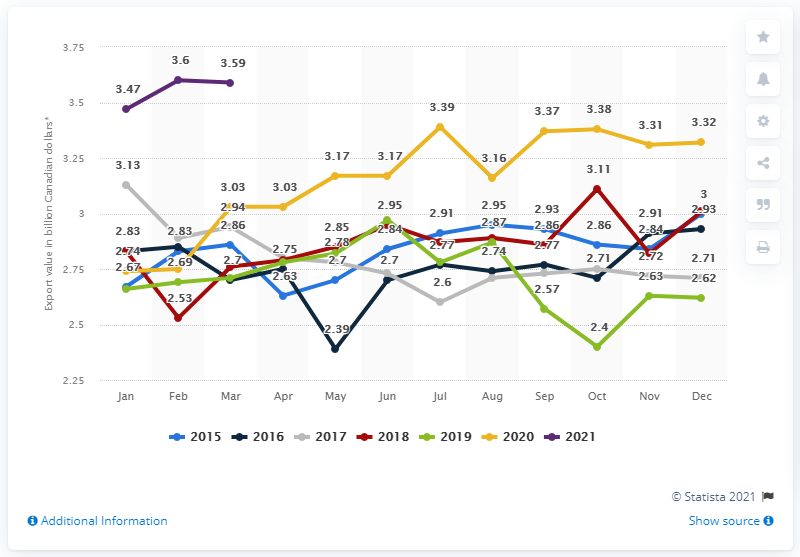Highlight a few significant elements in this photo. In March 2021, the value of exports of farm and fishing products from Canada was CAD 3.59 billion. 